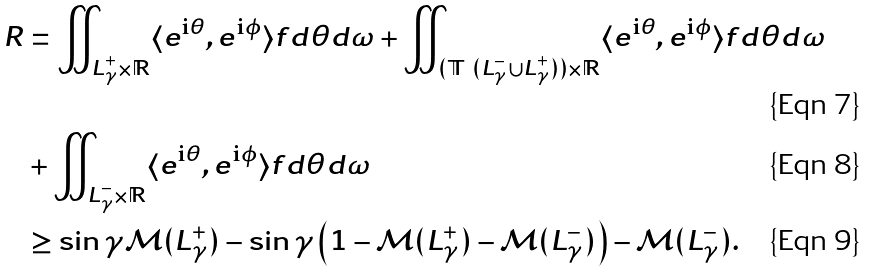Convert formula to latex. <formula><loc_0><loc_0><loc_500><loc_500>R & = \iint _ { L ^ { + } _ { \gamma } \times \mathbb { R } } \langle e ^ { { \mathrm i } \theta } , e ^ { { \mathrm i } \phi } \rangle f d \theta d \omega + \iint _ { ( \mathbb { T } \ ( L ^ { - } _ { \gamma } \cup L ^ { + } _ { \gamma } ) ) \times \mathbb { R } } \langle e ^ { { \mathrm i } \theta } , e ^ { { \mathrm i } \phi } \rangle f d \theta d \omega \\ & + \iint _ { L ^ { - } _ { \gamma } \times \mathbb { R } } \langle e ^ { { \mathrm i } \theta } , e ^ { { \mathrm i } \phi } \rangle f d \theta d \omega \\ & \geq \sin \gamma { \mathcal { M } } ( L ^ { + } _ { \gamma } ) - \sin \gamma \left ( 1 - { \mathcal { M } } ( L ^ { + } _ { \gamma } ) - { \mathcal { M } } ( L ^ { - } _ { \gamma } ) \right ) - { \mathcal { M } } ( L ^ { - } _ { \gamma } ) .</formula> 